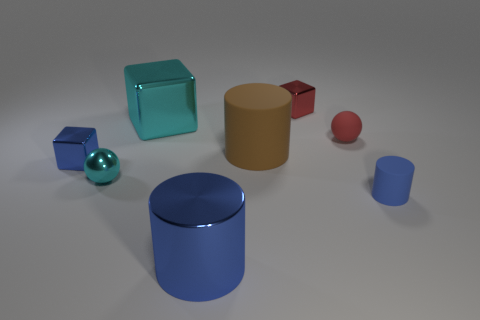There is a tiny shiny thing that is the same color as the tiny rubber cylinder; what shape is it?
Your answer should be very brief. Cube. Is there a tiny red ball in front of the cyan metal sphere on the left side of the object that is in front of the blue matte cylinder?
Your answer should be compact. No. How many things are blue shiny cylinders or tiny blue matte cubes?
Provide a succinct answer. 1. Are the large cube and the small block that is right of the tiny blue metal cube made of the same material?
Provide a short and direct response. Yes. Is there anything else of the same color as the small metal ball?
Make the answer very short. Yes. What number of objects are cylinders that are in front of the tiny cyan ball or small things that are in front of the large cyan thing?
Your response must be concise. 5. There is a small metallic object that is both behind the small cyan sphere and on the left side of the large shiny cylinder; what is its shape?
Keep it short and to the point. Cube. How many cubes are behind the big cylinder in front of the small blue matte cylinder?
Make the answer very short. 3. Is there anything else that is made of the same material as the tiny blue block?
Offer a very short reply. Yes. How many objects are metal cubes that are to the right of the blue metal block or large gray things?
Ensure brevity in your answer.  2. 